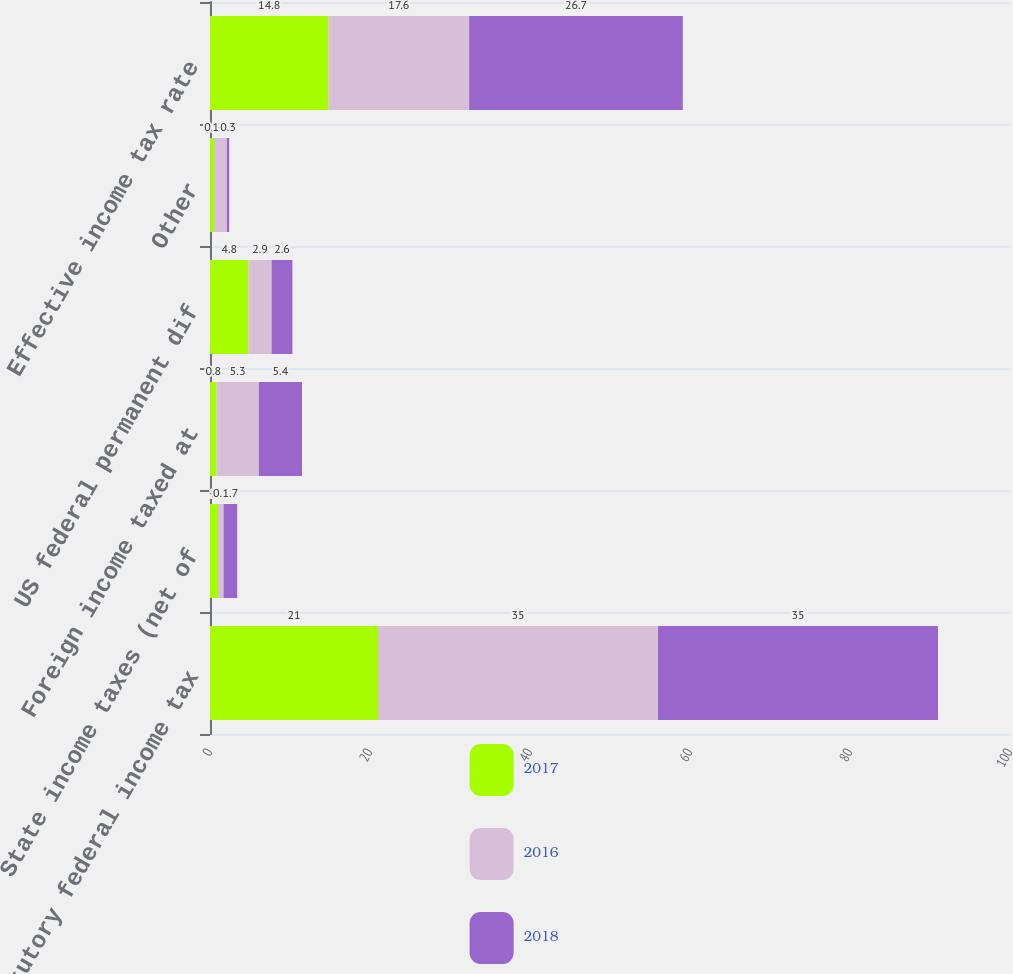Convert chart. <chart><loc_0><loc_0><loc_500><loc_500><stacked_bar_chart><ecel><fcel>Statutory federal income tax<fcel>State income taxes (net of<fcel>Foreign income taxed at<fcel>US federal permanent dif<fcel>Other<fcel>Effective income tax rate<nl><fcel>2017<fcel>21<fcel>1<fcel>0.8<fcel>4.8<fcel>0.5<fcel>14.8<nl><fcel>2016<fcel>35<fcel>0.7<fcel>5.3<fcel>2.9<fcel>1.6<fcel>17.6<nl><fcel>2018<fcel>35<fcel>1.7<fcel>5.4<fcel>2.6<fcel>0.3<fcel>26.7<nl></chart> 